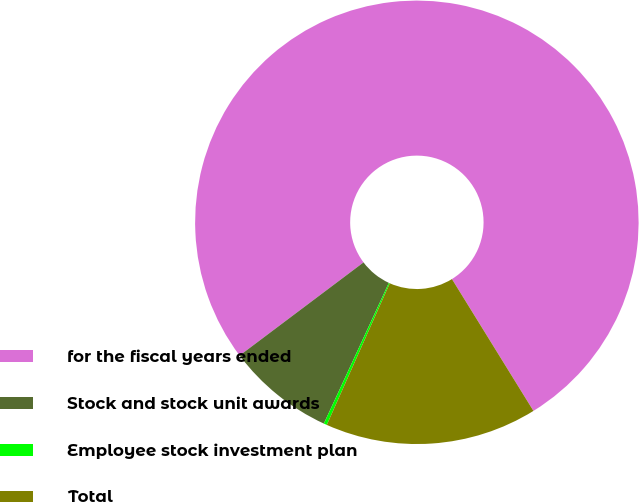Convert chart. <chart><loc_0><loc_0><loc_500><loc_500><pie_chart><fcel>for the fiscal years ended<fcel>Stock and stock unit awards<fcel>Employee stock investment plan<fcel>Total<nl><fcel>76.44%<fcel>7.85%<fcel>0.23%<fcel>15.47%<nl></chart> 